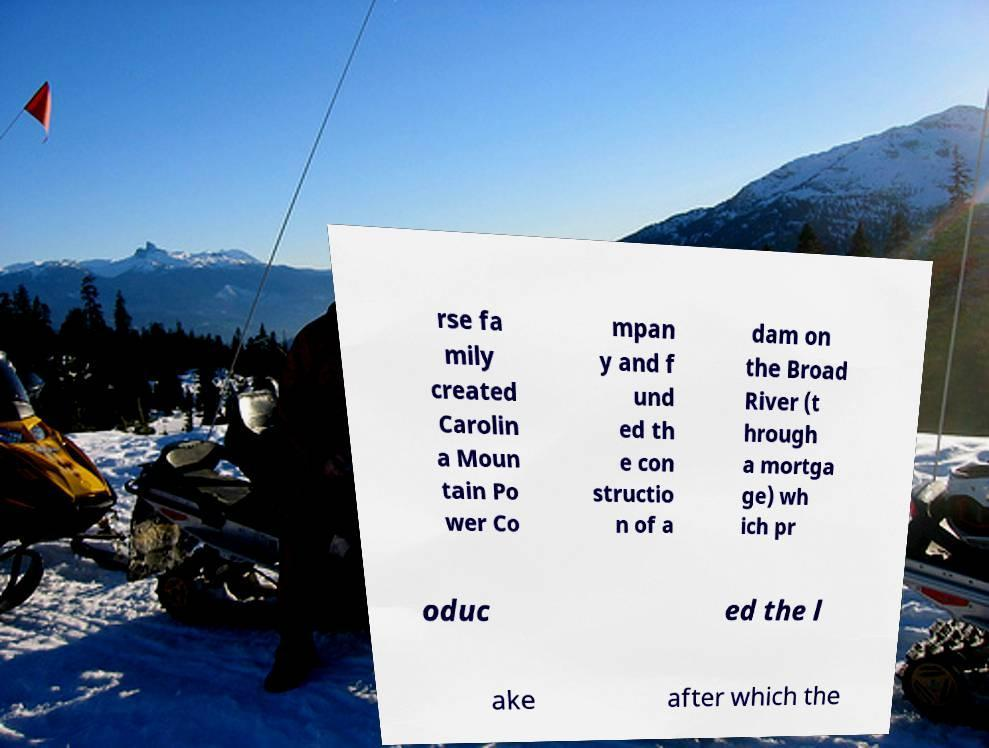Could you extract and type out the text from this image? rse fa mily created Carolin a Moun tain Po wer Co mpan y and f und ed th e con structio n of a dam on the Broad River (t hrough a mortga ge) wh ich pr oduc ed the l ake after which the 